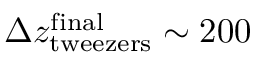<formula> <loc_0><loc_0><loc_500><loc_500>\Delta z _ { t w e e z e r s } ^ { f i n a l } \sim 2 0 0</formula> 